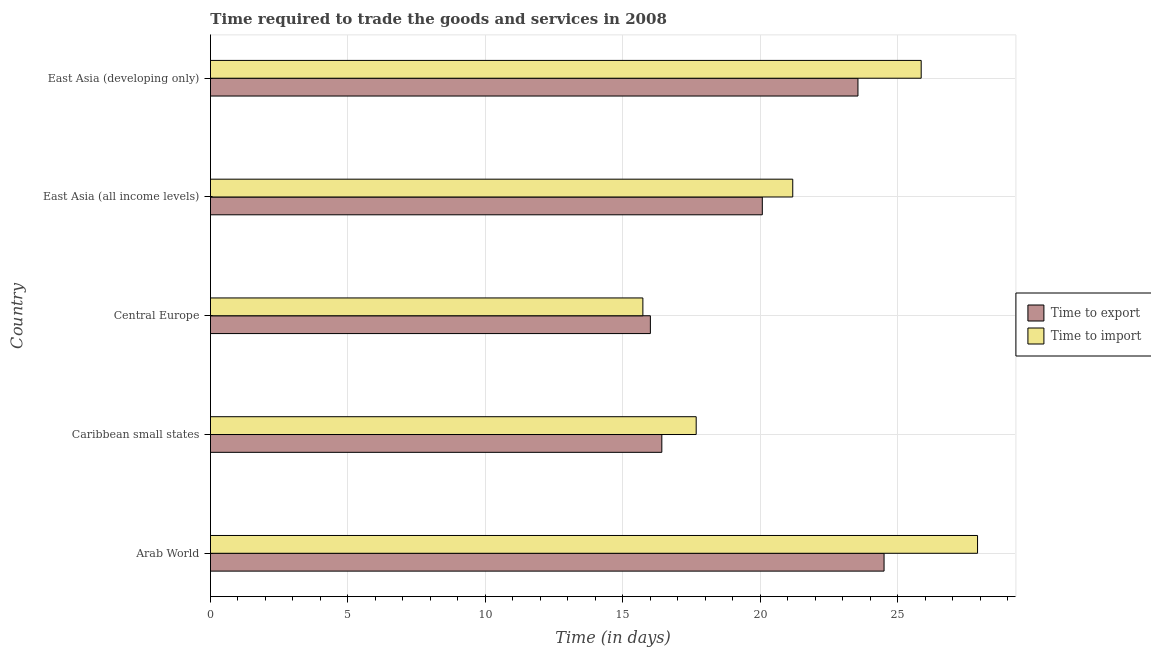How many different coloured bars are there?
Offer a very short reply. 2. How many groups of bars are there?
Offer a very short reply. 5. How many bars are there on the 3rd tick from the top?
Give a very brief answer. 2. How many bars are there on the 2nd tick from the bottom?
Keep it short and to the point. 2. What is the label of the 4th group of bars from the top?
Offer a very short reply. Caribbean small states. In how many cases, is the number of bars for a given country not equal to the number of legend labels?
Provide a short and direct response. 0. What is the time to import in Caribbean small states?
Your answer should be compact. 17.67. Across all countries, what is the maximum time to export?
Offer a terse response. 24.5. Across all countries, what is the minimum time to import?
Provide a succinct answer. 15.73. In which country was the time to export maximum?
Ensure brevity in your answer.  Arab World. In which country was the time to export minimum?
Ensure brevity in your answer.  Central Europe. What is the total time to import in the graph?
Offer a terse response. 108.32. What is the difference between the time to import in Arab World and that in East Asia (developing only)?
Your response must be concise. 2.05. What is the difference between the time to export in Central Europe and the time to import in East Asia (all income levels)?
Give a very brief answer. -5.18. What is the average time to export per country?
Keep it short and to the point. 20.11. What is the difference between the time to import and time to export in East Asia (all income levels)?
Keep it short and to the point. 1.11. In how many countries, is the time to export greater than 23 days?
Your answer should be compact. 2. What is the ratio of the time to export in Central Europe to that in East Asia (all income levels)?
Offer a terse response. 0.8. Is the difference between the time to import in Central Europe and East Asia (developing only) greater than the difference between the time to export in Central Europe and East Asia (developing only)?
Provide a succinct answer. No. What is the difference between the highest and the second highest time to export?
Offer a very short reply. 0.95. What is the difference between the highest and the lowest time to import?
Make the answer very short. 12.17. In how many countries, is the time to export greater than the average time to export taken over all countries?
Offer a terse response. 2. Is the sum of the time to export in Arab World and East Asia (developing only) greater than the maximum time to import across all countries?
Give a very brief answer. Yes. What does the 1st bar from the top in Caribbean small states represents?
Your response must be concise. Time to import. What does the 1st bar from the bottom in Arab World represents?
Provide a succinct answer. Time to export. How many countries are there in the graph?
Ensure brevity in your answer.  5. What is the difference between two consecutive major ticks on the X-axis?
Give a very brief answer. 5. Are the values on the major ticks of X-axis written in scientific E-notation?
Your response must be concise. No. Does the graph contain any zero values?
Your answer should be compact. No. Does the graph contain grids?
Your response must be concise. Yes. What is the title of the graph?
Provide a succinct answer. Time required to trade the goods and services in 2008. What is the label or title of the X-axis?
Your answer should be very brief. Time (in days). What is the label or title of the Y-axis?
Make the answer very short. Country. What is the Time (in days) in Time to import in Arab World?
Your answer should be compact. 27.9. What is the Time (in days) in Time to export in Caribbean small states?
Your response must be concise. 16.42. What is the Time (in days) in Time to import in Caribbean small states?
Your answer should be compact. 17.67. What is the Time (in days) in Time to import in Central Europe?
Your answer should be very brief. 15.73. What is the Time (in days) in Time to export in East Asia (all income levels)?
Offer a very short reply. 20.07. What is the Time (in days) in Time to import in East Asia (all income levels)?
Provide a succinct answer. 21.18. What is the Time (in days) of Time to export in East Asia (developing only)?
Keep it short and to the point. 23.55. What is the Time (in days) in Time to import in East Asia (developing only)?
Provide a short and direct response. 25.85. Across all countries, what is the maximum Time (in days) of Time to import?
Offer a very short reply. 27.9. Across all countries, what is the minimum Time (in days) in Time to export?
Make the answer very short. 16. Across all countries, what is the minimum Time (in days) in Time to import?
Give a very brief answer. 15.73. What is the total Time (in days) of Time to export in the graph?
Your answer should be compact. 100.54. What is the total Time (in days) in Time to import in the graph?
Keep it short and to the point. 108.32. What is the difference between the Time (in days) of Time to export in Arab World and that in Caribbean small states?
Your response must be concise. 8.08. What is the difference between the Time (in days) in Time to import in Arab World and that in Caribbean small states?
Offer a very short reply. 10.23. What is the difference between the Time (in days) in Time to import in Arab World and that in Central Europe?
Give a very brief answer. 12.17. What is the difference between the Time (in days) in Time to export in Arab World and that in East Asia (all income levels)?
Keep it short and to the point. 4.43. What is the difference between the Time (in days) of Time to import in Arab World and that in East Asia (all income levels)?
Offer a terse response. 6.72. What is the difference between the Time (in days) in Time to import in Arab World and that in East Asia (developing only)?
Your response must be concise. 2.05. What is the difference between the Time (in days) of Time to export in Caribbean small states and that in Central Europe?
Ensure brevity in your answer.  0.42. What is the difference between the Time (in days) of Time to import in Caribbean small states and that in Central Europe?
Provide a short and direct response. 1.94. What is the difference between the Time (in days) in Time to export in Caribbean small states and that in East Asia (all income levels)?
Your response must be concise. -3.65. What is the difference between the Time (in days) in Time to import in Caribbean small states and that in East Asia (all income levels)?
Give a very brief answer. -3.51. What is the difference between the Time (in days) in Time to export in Caribbean small states and that in East Asia (developing only)?
Provide a succinct answer. -7.13. What is the difference between the Time (in days) of Time to import in Caribbean small states and that in East Asia (developing only)?
Offer a terse response. -8.18. What is the difference between the Time (in days) in Time to export in Central Europe and that in East Asia (all income levels)?
Ensure brevity in your answer.  -4.07. What is the difference between the Time (in days) in Time to import in Central Europe and that in East Asia (all income levels)?
Your answer should be compact. -5.45. What is the difference between the Time (in days) of Time to export in Central Europe and that in East Asia (developing only)?
Offer a very short reply. -7.55. What is the difference between the Time (in days) in Time to import in Central Europe and that in East Asia (developing only)?
Keep it short and to the point. -10.12. What is the difference between the Time (in days) in Time to export in East Asia (all income levels) and that in East Asia (developing only)?
Make the answer very short. -3.48. What is the difference between the Time (in days) of Time to import in East Asia (all income levels) and that in East Asia (developing only)?
Give a very brief answer. -4.67. What is the difference between the Time (in days) of Time to export in Arab World and the Time (in days) of Time to import in Caribbean small states?
Make the answer very short. 6.83. What is the difference between the Time (in days) in Time to export in Arab World and the Time (in days) in Time to import in Central Europe?
Offer a very short reply. 8.77. What is the difference between the Time (in days) in Time to export in Arab World and the Time (in days) in Time to import in East Asia (all income levels)?
Provide a succinct answer. 3.32. What is the difference between the Time (in days) in Time to export in Arab World and the Time (in days) in Time to import in East Asia (developing only)?
Your answer should be very brief. -1.35. What is the difference between the Time (in days) of Time to export in Caribbean small states and the Time (in days) of Time to import in Central Europe?
Give a very brief answer. 0.69. What is the difference between the Time (in days) in Time to export in Caribbean small states and the Time (in days) in Time to import in East Asia (all income levels)?
Your answer should be very brief. -4.76. What is the difference between the Time (in days) in Time to export in Caribbean small states and the Time (in days) in Time to import in East Asia (developing only)?
Keep it short and to the point. -9.43. What is the difference between the Time (in days) in Time to export in Central Europe and the Time (in days) in Time to import in East Asia (all income levels)?
Provide a short and direct response. -5.18. What is the difference between the Time (in days) of Time to export in Central Europe and the Time (in days) of Time to import in East Asia (developing only)?
Your answer should be compact. -9.85. What is the difference between the Time (in days) in Time to export in East Asia (all income levels) and the Time (in days) in Time to import in East Asia (developing only)?
Provide a short and direct response. -5.78. What is the average Time (in days) of Time to export per country?
Keep it short and to the point. 20.11. What is the average Time (in days) of Time to import per country?
Provide a succinct answer. 21.66. What is the difference between the Time (in days) in Time to export and Time (in days) in Time to import in Arab World?
Offer a terse response. -3.4. What is the difference between the Time (in days) of Time to export and Time (in days) of Time to import in Caribbean small states?
Ensure brevity in your answer.  -1.25. What is the difference between the Time (in days) in Time to export and Time (in days) in Time to import in Central Europe?
Your answer should be very brief. 0.27. What is the difference between the Time (in days) in Time to export and Time (in days) in Time to import in East Asia (all income levels)?
Your answer should be very brief. -1.11. What is the difference between the Time (in days) of Time to export and Time (in days) of Time to import in East Asia (developing only)?
Offer a very short reply. -2.3. What is the ratio of the Time (in days) of Time to export in Arab World to that in Caribbean small states?
Offer a terse response. 1.49. What is the ratio of the Time (in days) in Time to import in Arab World to that in Caribbean small states?
Keep it short and to the point. 1.58. What is the ratio of the Time (in days) in Time to export in Arab World to that in Central Europe?
Your answer should be very brief. 1.53. What is the ratio of the Time (in days) of Time to import in Arab World to that in Central Europe?
Your answer should be compact. 1.77. What is the ratio of the Time (in days) in Time to export in Arab World to that in East Asia (all income levels)?
Provide a short and direct response. 1.22. What is the ratio of the Time (in days) in Time to import in Arab World to that in East Asia (all income levels)?
Keep it short and to the point. 1.32. What is the ratio of the Time (in days) in Time to export in Arab World to that in East Asia (developing only)?
Your answer should be compact. 1.04. What is the ratio of the Time (in days) in Time to import in Arab World to that in East Asia (developing only)?
Provide a succinct answer. 1.08. What is the ratio of the Time (in days) of Time to export in Caribbean small states to that in Central Europe?
Offer a very short reply. 1.03. What is the ratio of the Time (in days) of Time to import in Caribbean small states to that in Central Europe?
Provide a succinct answer. 1.12. What is the ratio of the Time (in days) of Time to export in Caribbean small states to that in East Asia (all income levels)?
Your response must be concise. 0.82. What is the ratio of the Time (in days) of Time to import in Caribbean small states to that in East Asia (all income levels)?
Provide a short and direct response. 0.83. What is the ratio of the Time (in days) in Time to export in Caribbean small states to that in East Asia (developing only)?
Offer a terse response. 0.7. What is the ratio of the Time (in days) in Time to import in Caribbean small states to that in East Asia (developing only)?
Keep it short and to the point. 0.68. What is the ratio of the Time (in days) of Time to export in Central Europe to that in East Asia (all income levels)?
Offer a very short reply. 0.8. What is the ratio of the Time (in days) of Time to import in Central Europe to that in East Asia (all income levels)?
Ensure brevity in your answer.  0.74. What is the ratio of the Time (in days) of Time to export in Central Europe to that in East Asia (developing only)?
Your answer should be very brief. 0.68. What is the ratio of the Time (in days) in Time to import in Central Europe to that in East Asia (developing only)?
Provide a succinct answer. 0.61. What is the ratio of the Time (in days) of Time to export in East Asia (all income levels) to that in East Asia (developing only)?
Keep it short and to the point. 0.85. What is the ratio of the Time (in days) in Time to import in East Asia (all income levels) to that in East Asia (developing only)?
Give a very brief answer. 0.82. What is the difference between the highest and the second highest Time (in days) in Time to export?
Offer a terse response. 0.95. What is the difference between the highest and the second highest Time (in days) of Time to import?
Your answer should be very brief. 2.05. What is the difference between the highest and the lowest Time (in days) in Time to import?
Make the answer very short. 12.17. 